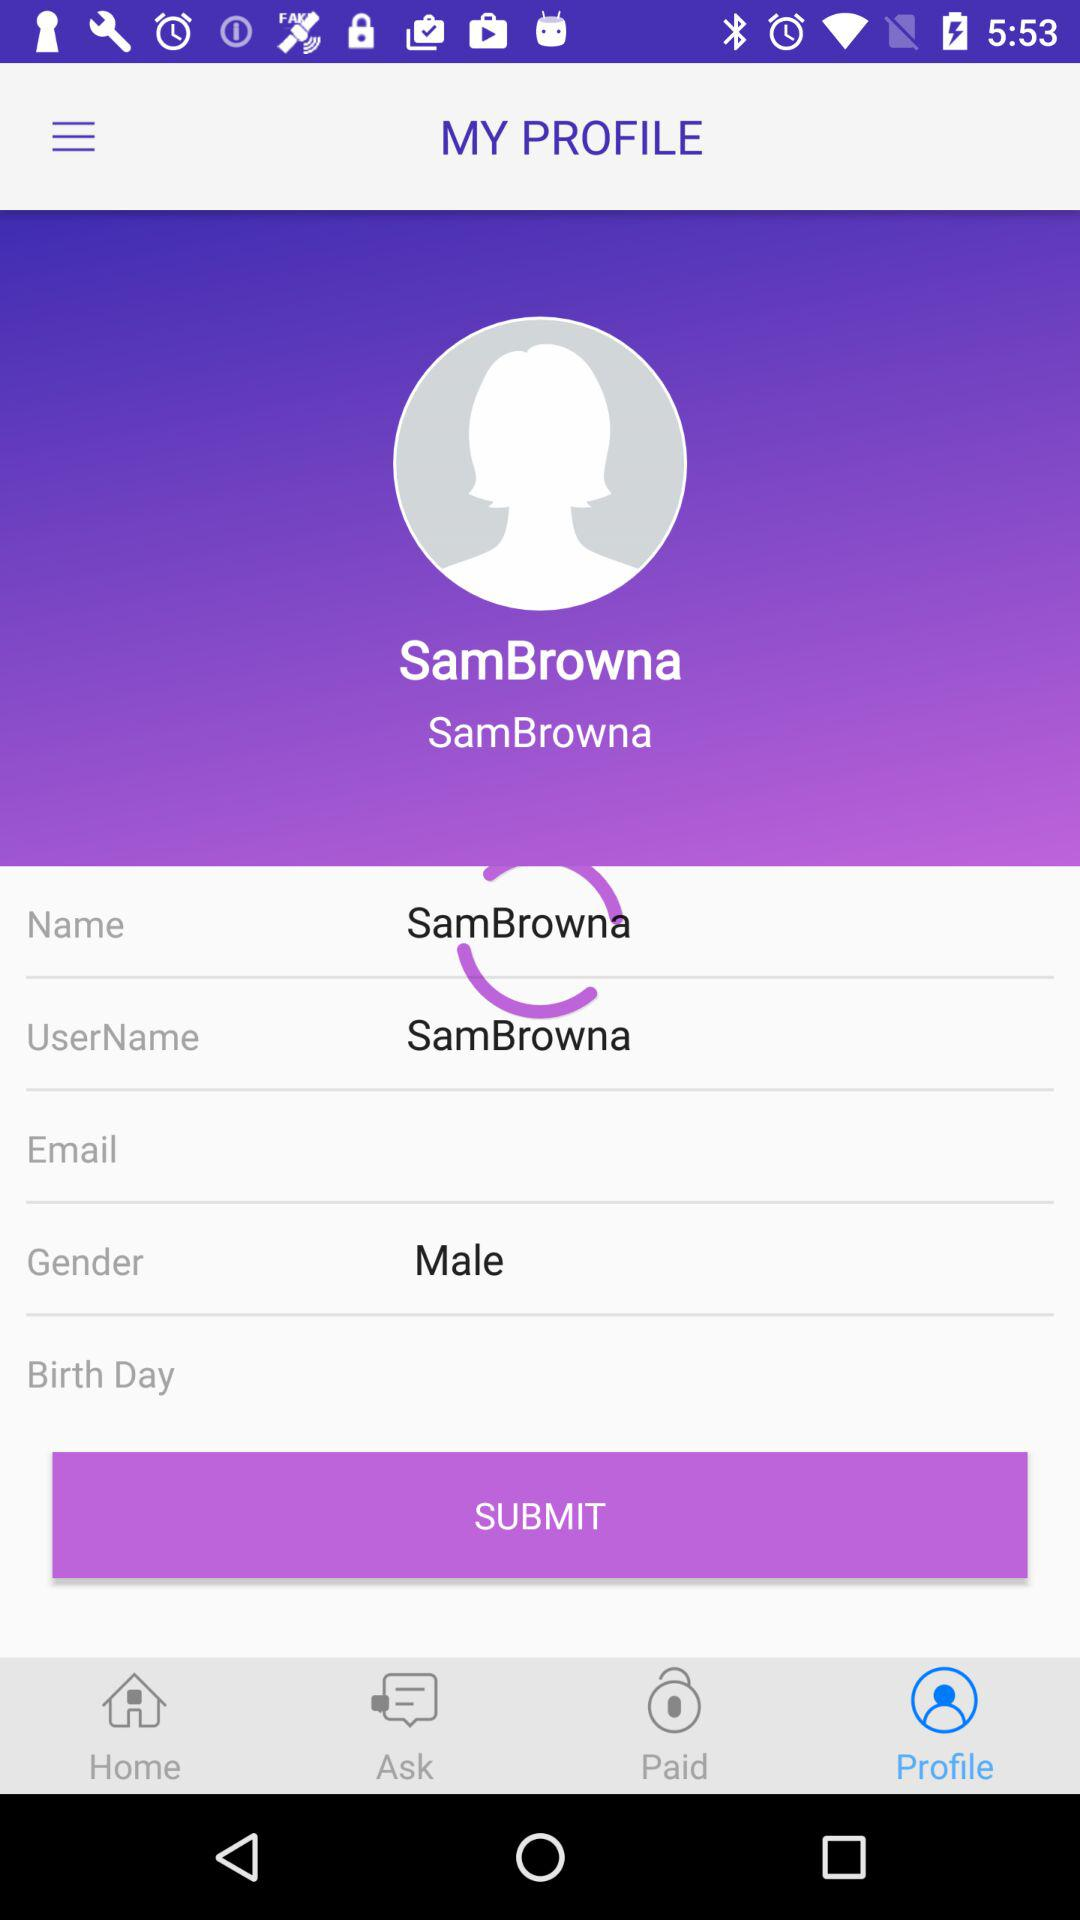What is the username? The username is "SamBrowna". 